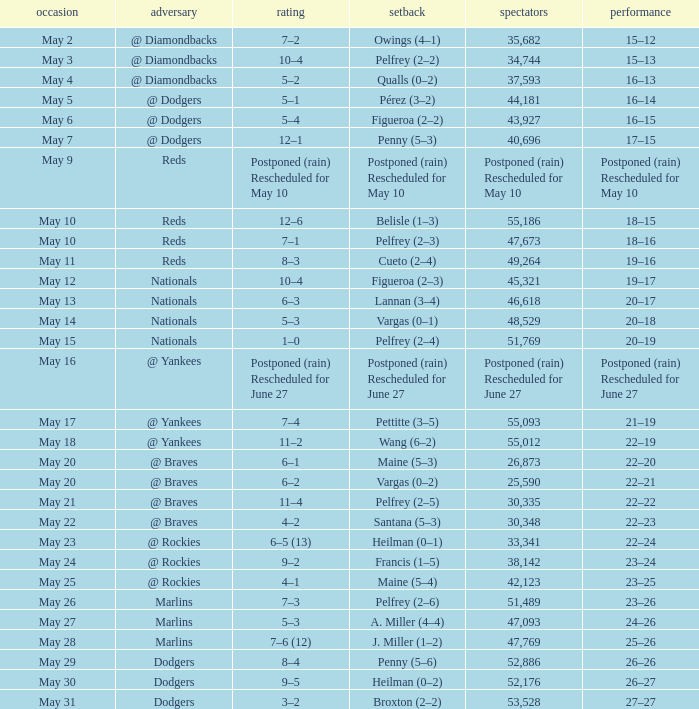Record of 22–20 involved what score? 6–1. 